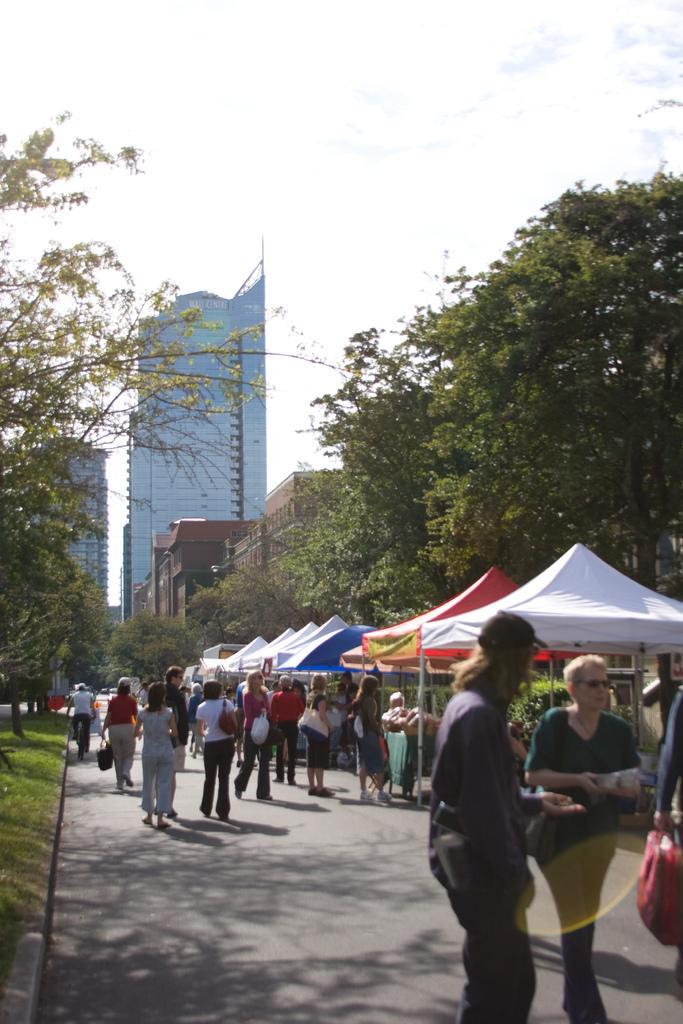Could you give a brief overview of what you see in this image? In this image we can see sky, trees, buildings, ground, persons standing on the ground and tents. 